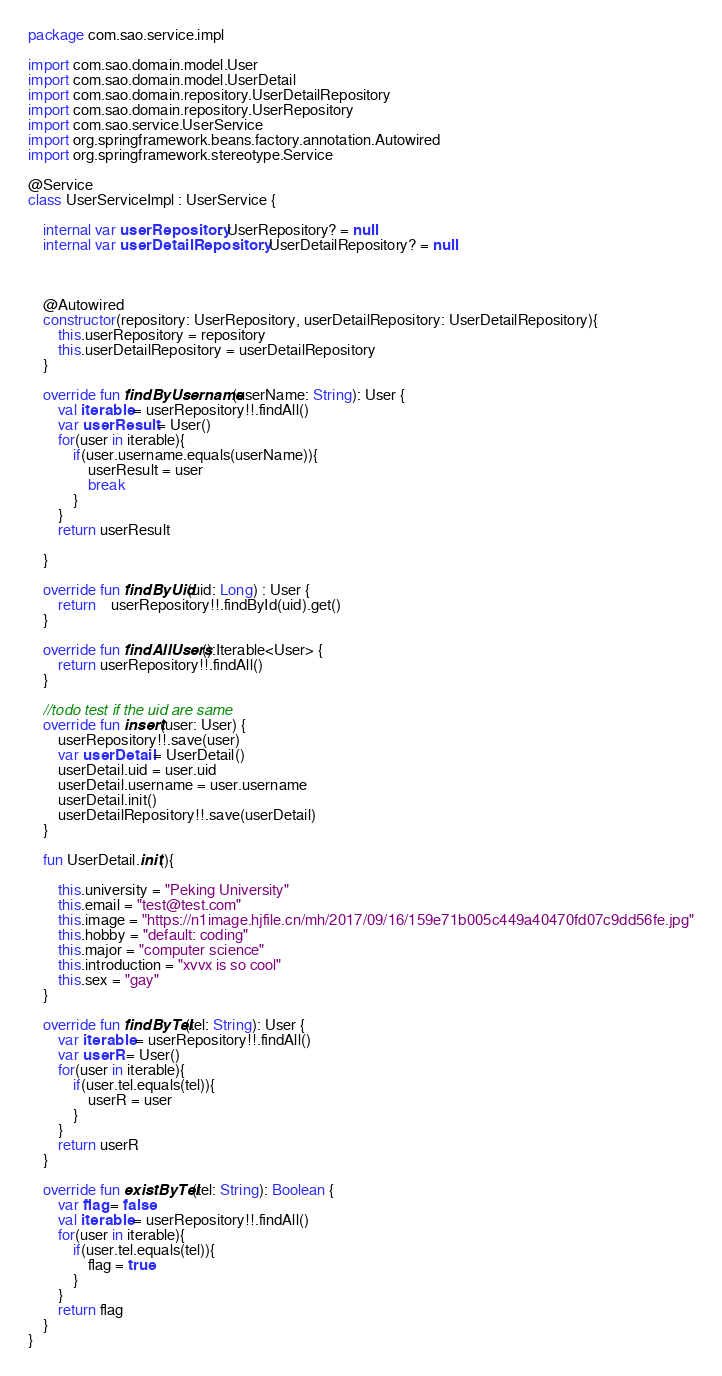Convert code to text. <code><loc_0><loc_0><loc_500><loc_500><_Kotlin_>package com.sao.service.impl

import com.sao.domain.model.User
import com.sao.domain.model.UserDetail
import com.sao.domain.repository.UserDetailRepository
import com.sao.domain.repository.UserRepository
import com.sao.service.UserService
import org.springframework.beans.factory.annotation.Autowired
import org.springframework.stereotype.Service

@Service
class UserServiceImpl : UserService {

    internal var userRepository: UserRepository? = null
    internal var userDetailRepository : UserDetailRepository? = null



    @Autowired
    constructor(repository: UserRepository, userDetailRepository: UserDetailRepository){
        this.userRepository = repository
        this.userDetailRepository = userDetailRepository
    }

    override fun findByUsername(userName: String): User {
        val iterable = userRepository!!.findAll()
        var userResult = User()
        for(user in iterable){
            if(user.username.equals(userName)){
                userResult = user
                break
            }
        }
        return userResult

    }

    override fun findByUid(uid: Long) : User {
        return    userRepository!!.findById(uid).get()
    }

    override fun findAllUsers():Iterable<User> {
        return userRepository!!.findAll()
    }

    //todo test if the uid are same
    override fun insert(user: User) {
        userRepository!!.save(user)
        var userDetail = UserDetail()
        userDetail.uid = user.uid
        userDetail.username = user.username
        userDetail.init()
        userDetailRepository!!.save(userDetail)
    }

    fun UserDetail.init(){

        this.university = "Peking University"
        this.email = "test@test.com"
        this.image = "https://n1image.hjfile.cn/mh/2017/09/16/159e71b005c449a40470fd07c9dd56fe.jpg"
        this.hobby = "default: coding"
        this.major = "computer science"
        this.introduction = "xvvx is so cool"
        this.sex = "gay"
    }

    override fun findByTel(tel: String): User {
        var iterable = userRepository!!.findAll()
        var userR = User()
        for(user in iterable){
            if(user.tel.equals(tel)){
                userR = user
            }
        }
        return userR
    }

    override fun existByTel(tel: String): Boolean {
        var flag = false
        val iterable = userRepository!!.findAll()
        for(user in iterable){
            if(user.tel.equals(tel)){
                flag = true
            }
        }
        return flag
    }
}
</code> 